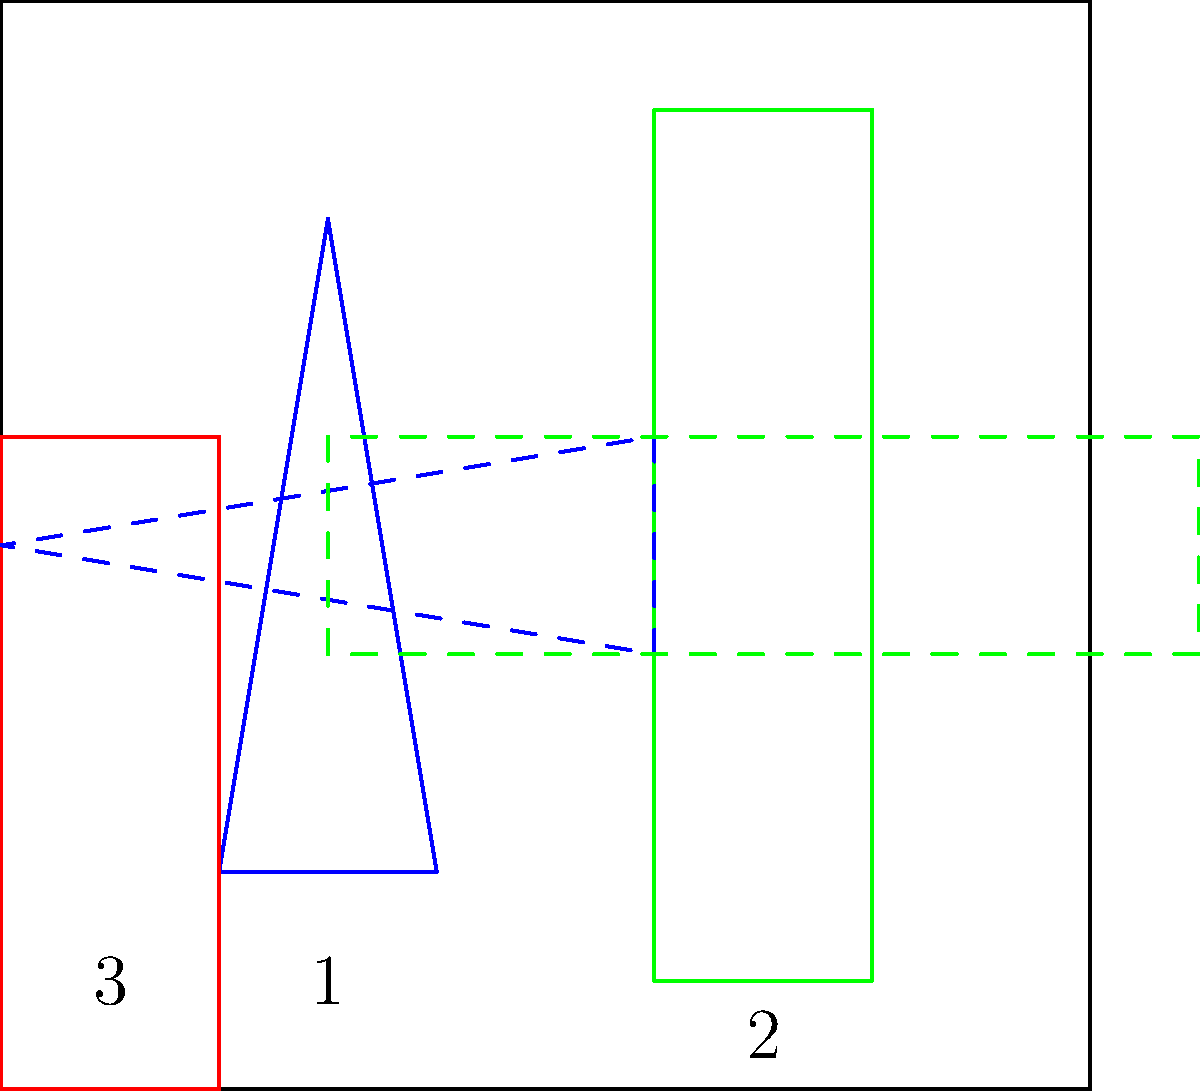In the storage rack shown above, three garden tools need to be arranged efficiently. The blue spade (1) needs to be rotated 90° clockwise, the green rake (2) needs to be rotated 90° counterclockwise, and the red hoe (3) needs to be rotated 180°. After rotating, which tool will occupy the leftmost position in the rack? To solve this problem, we need to visualize the rotation of each tool and their final positions:

1. The blue spade (1):
   - Currently vertical on the left side
   - After 90° clockwise rotation, it will be horizontal at the bottom of the rack

2. The green rake (2):
   - Currently vertical on the right side
   - After 90° counterclockwise rotation, it will be horizontal at the top of the rack

3. The red hoe (3):
   - Currently vertical on the far left
   - After 180° rotation, it will remain vertical on the far left

After these rotations:
- The spade will be at the bottom
- The rake will be at the top
- The hoe will remain on the far left

Therefore, the red hoe (3) will occupy the leftmost position in the rack after all rotations are completed.
Answer: Red hoe (3) 